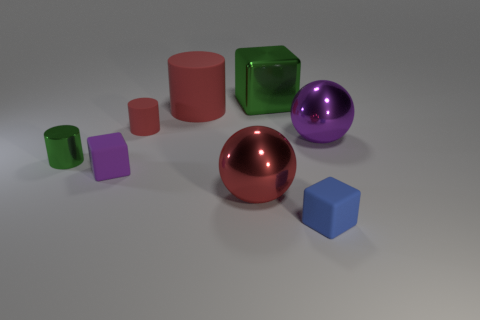Subtract all large green cubes. How many cubes are left? 2 Subtract all gray blocks. How many red cylinders are left? 2 Add 1 red matte objects. How many objects exist? 9 Subtract all cylinders. How many objects are left? 5 Subtract all green blocks. How many blocks are left? 2 Subtract 1 cylinders. How many cylinders are left? 2 Add 3 green blocks. How many green blocks are left? 4 Add 5 big yellow things. How many big yellow things exist? 5 Subtract 1 green cylinders. How many objects are left? 7 Subtract all blue cylinders. Subtract all brown spheres. How many cylinders are left? 3 